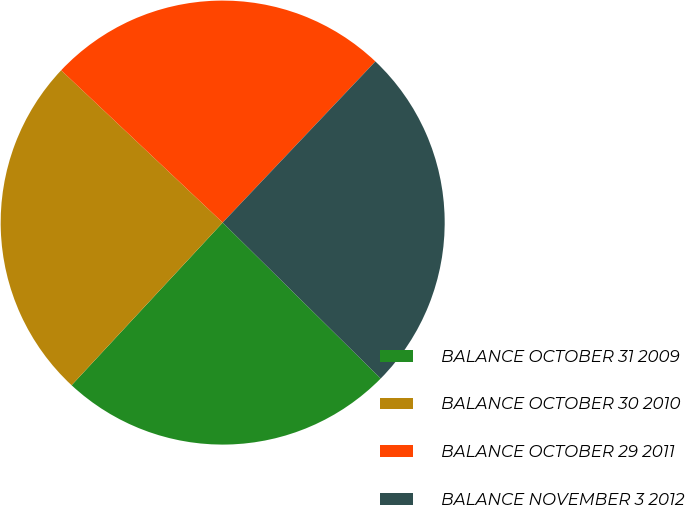<chart> <loc_0><loc_0><loc_500><loc_500><pie_chart><fcel>BALANCE OCTOBER 31 2009<fcel>BALANCE OCTOBER 30 2010<fcel>BALANCE OCTOBER 29 2011<fcel>BALANCE NOVEMBER 3 2012<nl><fcel>24.52%<fcel>25.12%<fcel>25.04%<fcel>25.32%<nl></chart> 